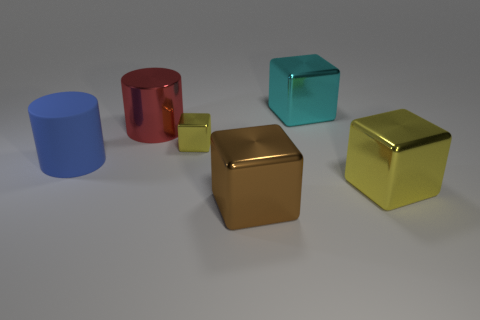Is the size of the blue cylinder the same as the cyan cube?
Make the answer very short. Yes. Is there a big metal thing behind the big thing that is on the left side of the big metal thing left of the brown block?
Your answer should be compact. Yes. What is the material of the big blue thing that is the same shape as the red metallic thing?
Your answer should be compact. Rubber. There is a big cylinder that is behind the big blue cylinder; what is its color?
Your answer should be very brief. Red. Do the matte object and the yellow thing to the right of the big brown block have the same size?
Keep it short and to the point. Yes. What is the color of the metal block behind the yellow thing behind the big metallic thing that is to the right of the cyan block?
Keep it short and to the point. Cyan. Is the yellow block that is in front of the blue cylinder made of the same material as the cyan cube?
Offer a terse response. Yes. How many other things are there of the same material as the large blue cylinder?
Offer a terse response. 0. What is the material of the blue object that is the same size as the cyan block?
Your response must be concise. Rubber. There is a yellow thing that is in front of the small cube; does it have the same shape as the yellow thing that is behind the big blue matte cylinder?
Provide a succinct answer. Yes. 